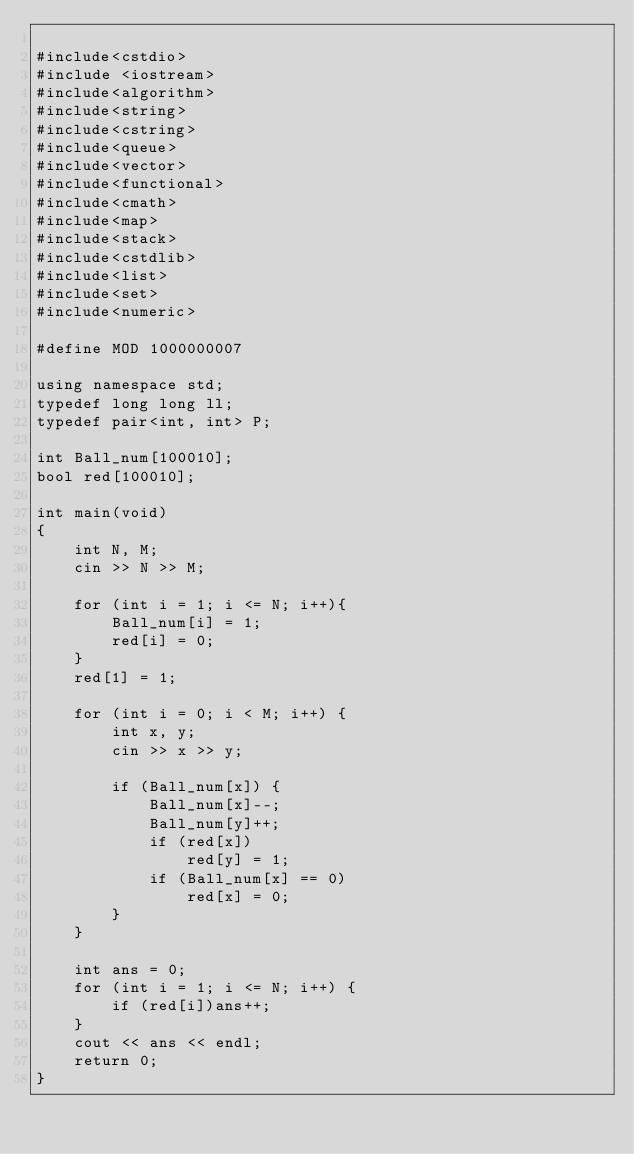<code> <loc_0><loc_0><loc_500><loc_500><_C++_>
#include<cstdio>
#include <iostream>
#include<algorithm>
#include<string>
#include<cstring>
#include<queue>
#include<vector>
#include<functional>
#include<cmath>
#include<map>
#include<stack>
#include<cstdlib>
#include<list>
#include<set>
#include<numeric>

#define MOD 1000000007

using namespace std;
typedef long long ll;
typedef pair<int, int> P;

int Ball_num[100010];
bool red[100010];

int main(void)
{
	int N, M;
	cin >> N >> M;

	for (int i = 1; i <= N; i++){
		Ball_num[i] = 1;
		red[i] = 0;
	}
	red[1] = 1;

	for (int i = 0; i < M; i++) {
		int x, y;
		cin >> x >> y;
	
		if (Ball_num[x]) {
			Ball_num[x]--;
			Ball_num[y]++;
			if (red[x])
				red[y] = 1;
			if (Ball_num[x] == 0)
				red[x] = 0;
		}
	}

	int ans = 0;
	for (int i = 1; i <= N; i++) {
		if (red[i])ans++;
	}
	cout << ans << endl;
	return 0;
}</code> 